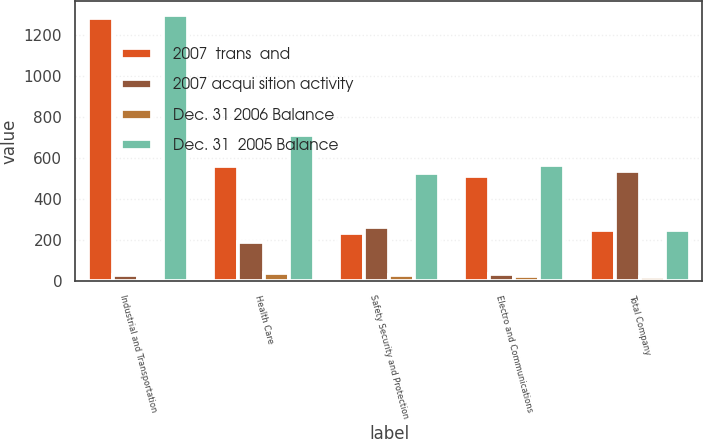Convert chart to OTSL. <chart><loc_0><loc_0><loc_500><loc_500><stacked_bar_chart><ecel><fcel>Industrial and Transportation<fcel>Health Care<fcel>Safety Security and Protection<fcel>Electro and Communications<fcel>Total Company<nl><fcel>2007  trans  and<fcel>1283<fcel>559<fcel>234<fcel>512<fcel>249<nl><fcel>2007 acqui sition activity<fcel>26<fcel>191<fcel>264<fcel>32<fcel>536<nl><fcel>Dec. 31 2006 Balance<fcel>7<fcel>37<fcel>27<fcel>23<fcel>16<nl><fcel>Dec. 31  2005 Balance<fcel>1302<fcel>713<fcel>525<fcel>567<fcel>249<nl></chart> 